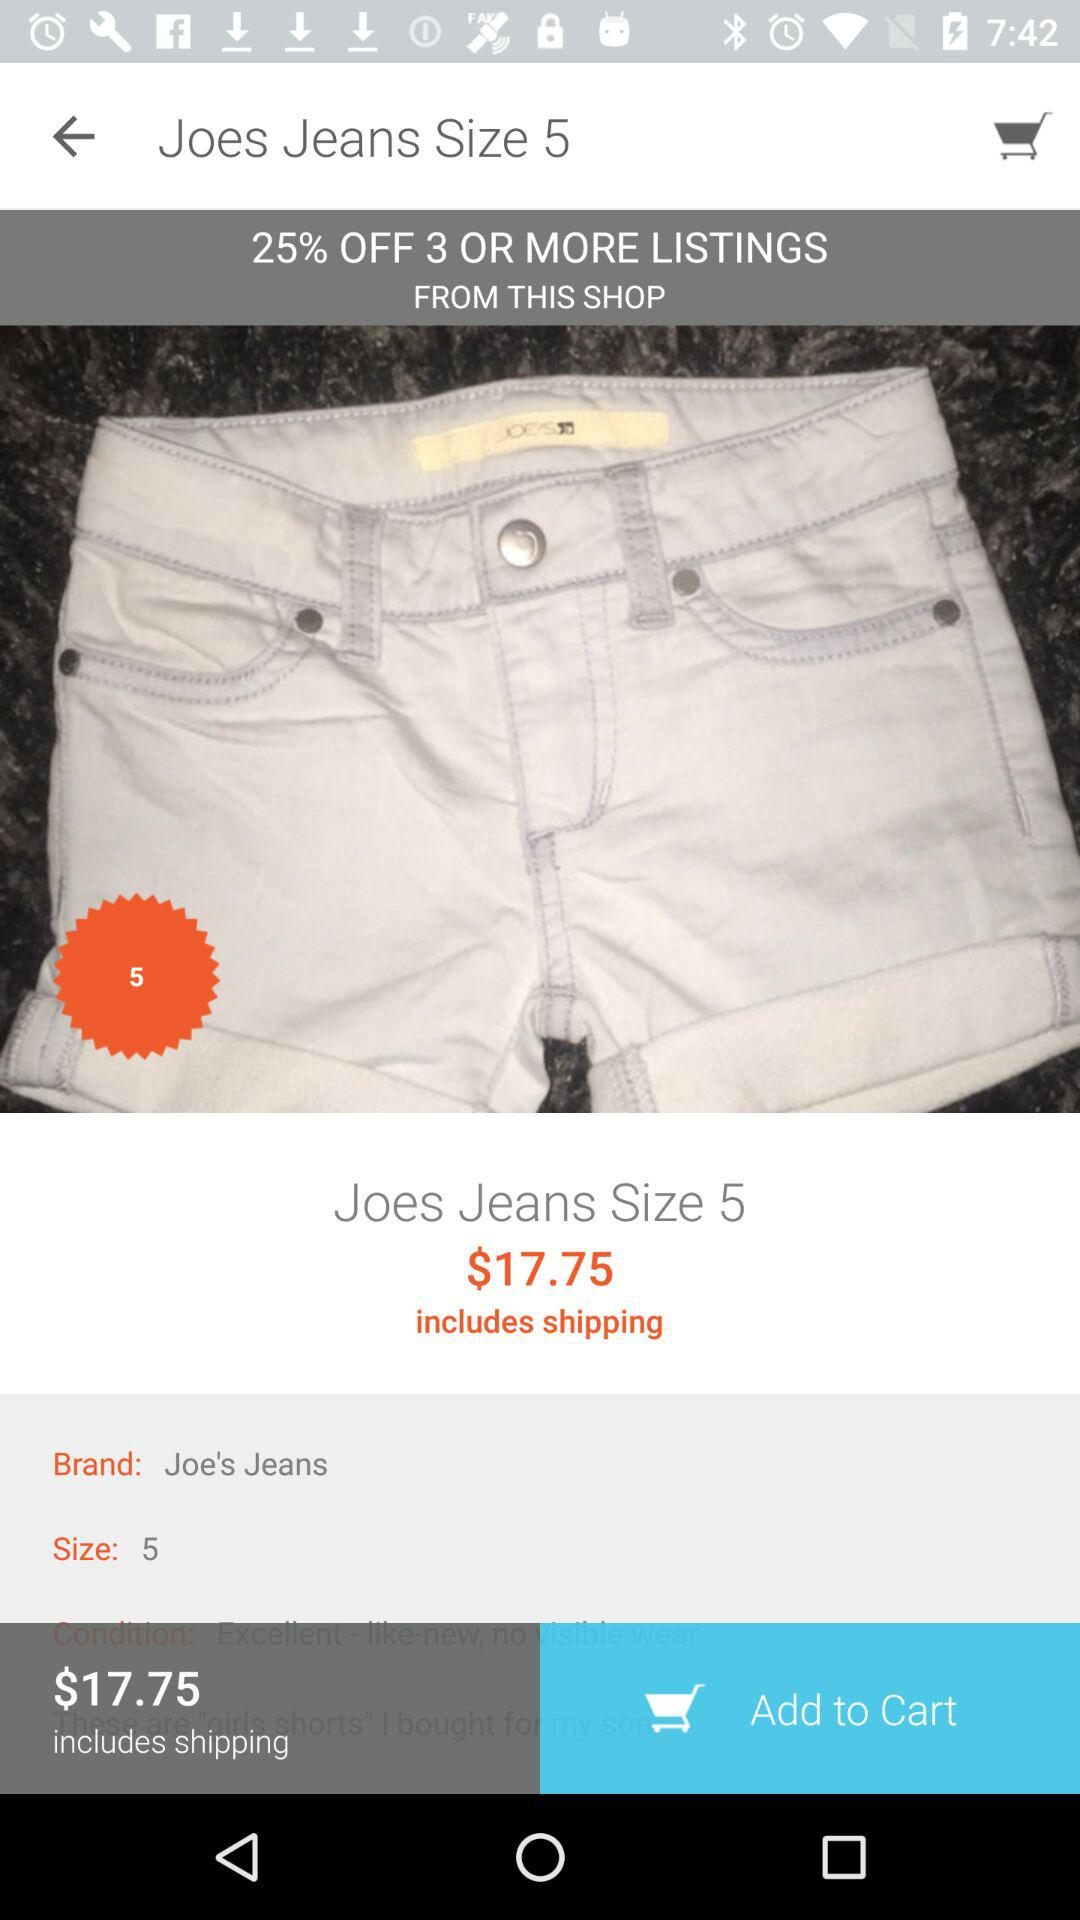What is the size of Joe's jeans? The size of Joe's jeans is 5. 